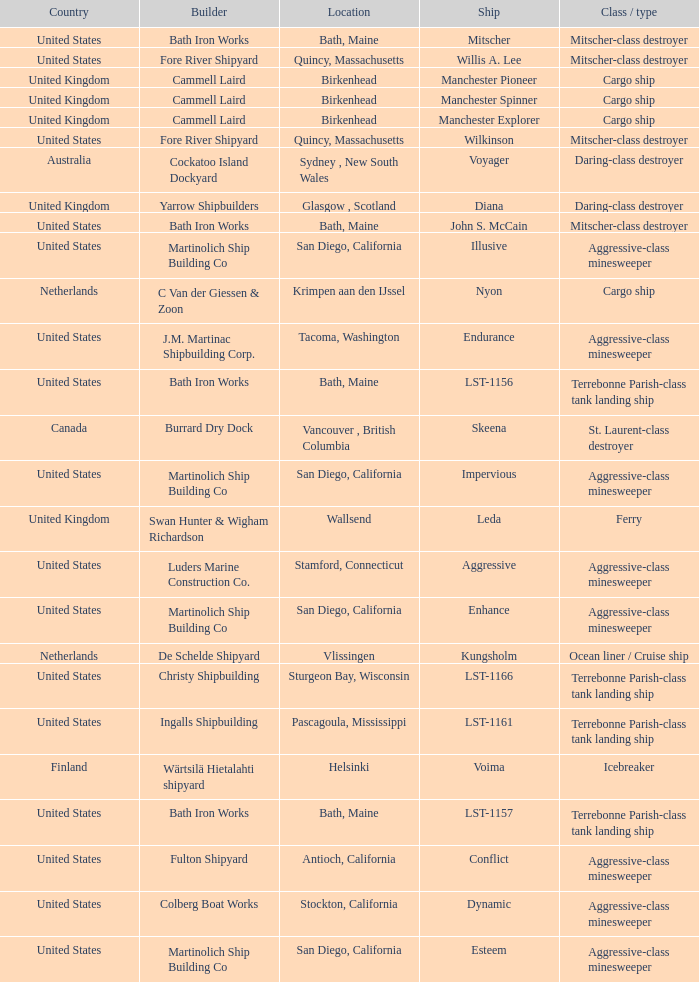The john s. mccain ship is from which country? United States. 